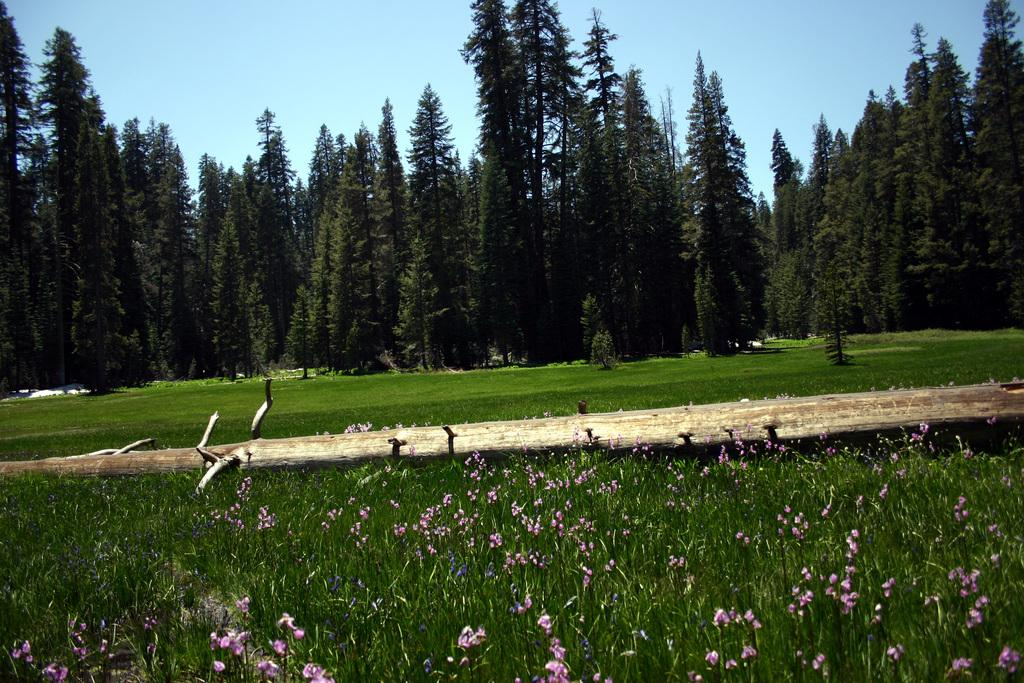What type of plants can be seen in the image? There are flower plants in the image. What type of vegetation is present besides the flower plants? There is grass in the image. What else can be seen in the image that is related to plants? There are branches and trees in the image. What is visible in the background of the image? The sky is visible in the image. Where is the queen walking along the street in the image? There is no queen or street present in the image; it features plants, grass, branches, trees, and the sky. 